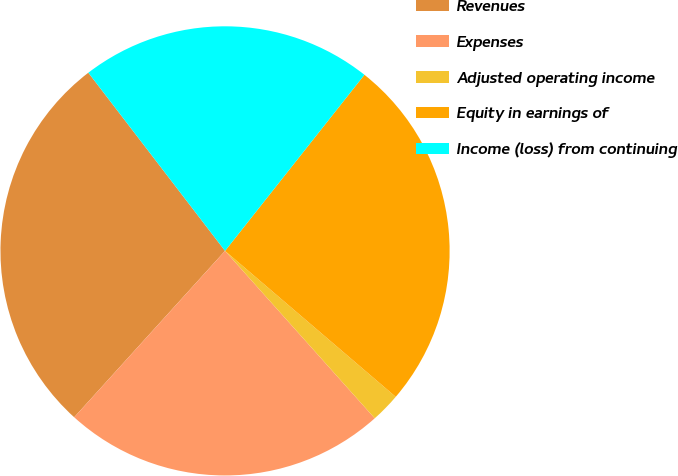Convert chart to OTSL. <chart><loc_0><loc_0><loc_500><loc_500><pie_chart><fcel>Revenues<fcel>Expenses<fcel>Adjusted operating income<fcel>Equity in earnings of<fcel>Income (loss) from continuing<nl><fcel>27.86%<fcel>23.33%<fcel>2.13%<fcel>25.6%<fcel>21.07%<nl></chart> 